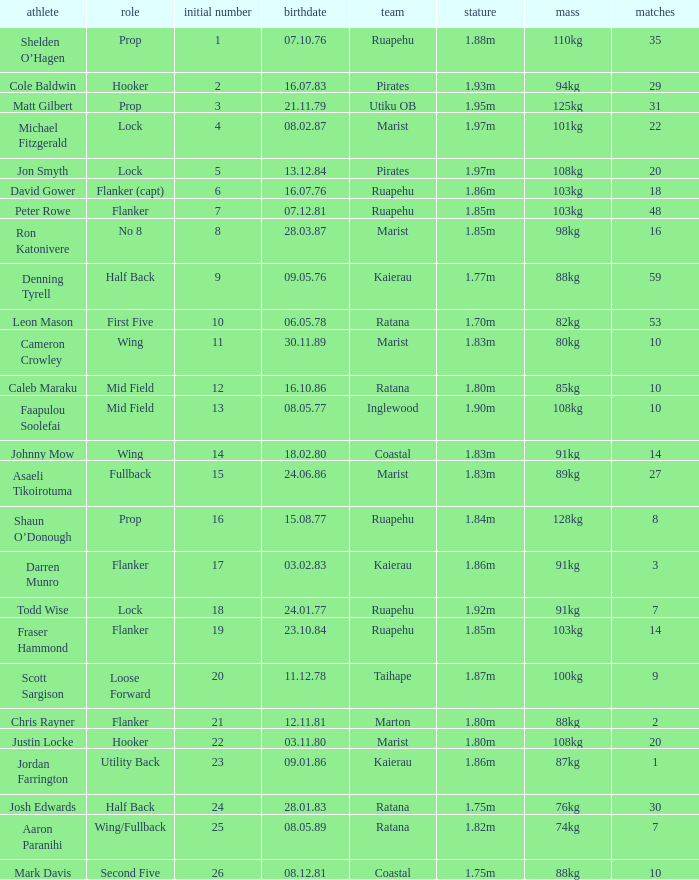What position does the player Todd Wise play in? Lock. 